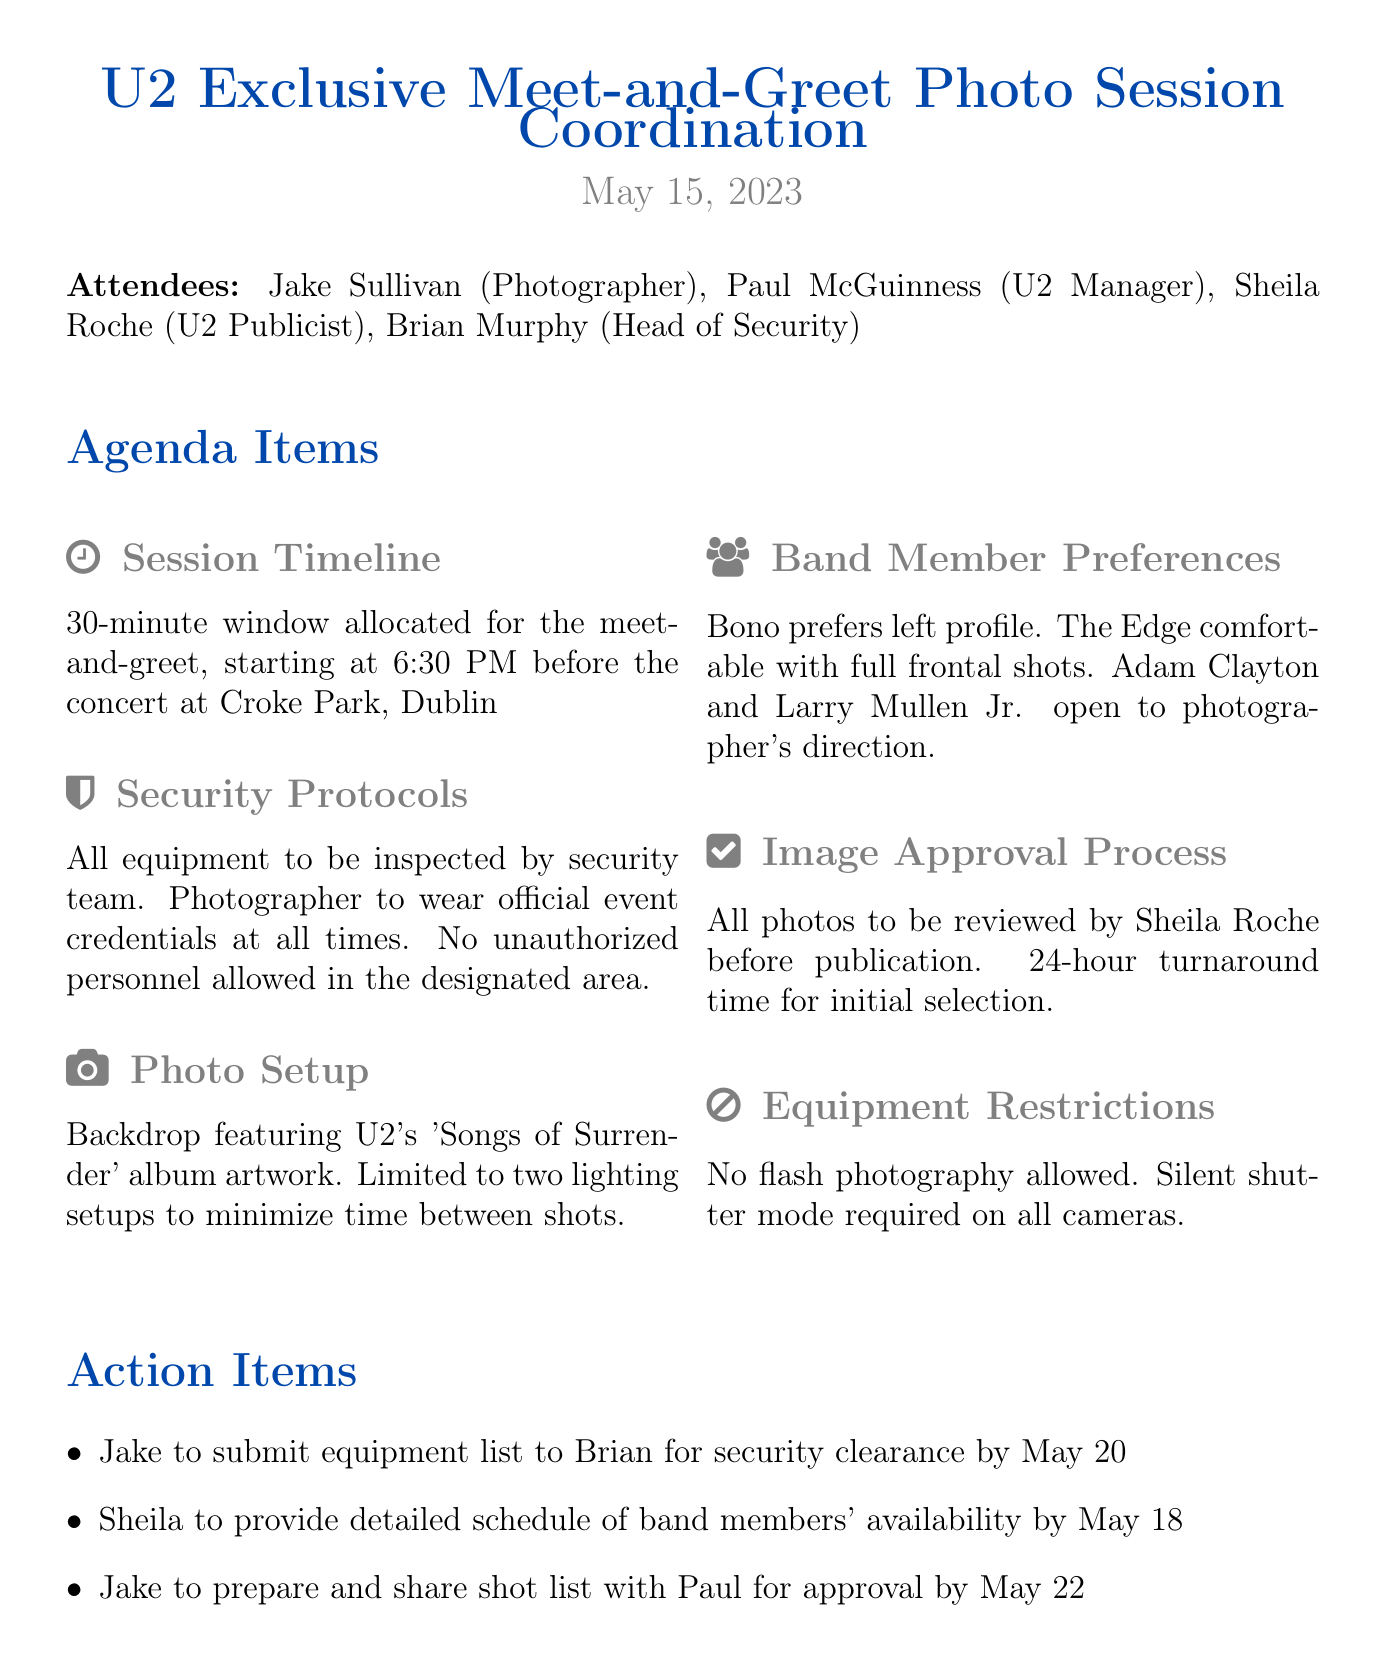What is the date of the meeting? The date of the meeting is explicitly stated in the document's header.
Answer: May 15, 2023 Who is responsible for security clearance of the equipment? The action item specifies that Jake needs to submit the equipment list to Brian for security clearance.
Answer: Brian What time does the meet-and-greet session start? The session timeline section clearly mentions the starting time of the event.
Answer: 6:30 PM How long is the allocated time for the meet-and-greet? The document specifies that there is a 30-minute window for the event.
Answer: 30 minutes What is prohibited during the photo session? The equipment restrictions section mentions that certain photography methods are not allowed during the event.
Answer: Flash photography Which U2 band member prefers to be photographed from the left profile? The preferences section identifies which band member has a specific request regarding their photo.
Answer: Bono What type of backdrop will be used for the photos? The photo setup section describes the type of backdrop that will be featured during the session.
Answer: 'Songs of Surrender' album artwork What is the turnaround time for photo selection approval? The image approval process outlines the time frame for reviewing the photos before publication.
Answer: 24-hour What is the deadline for Jake to share the shot list with Paul? The action items indicate the specific date by which Jake must complete this task.
Answer: May 22 